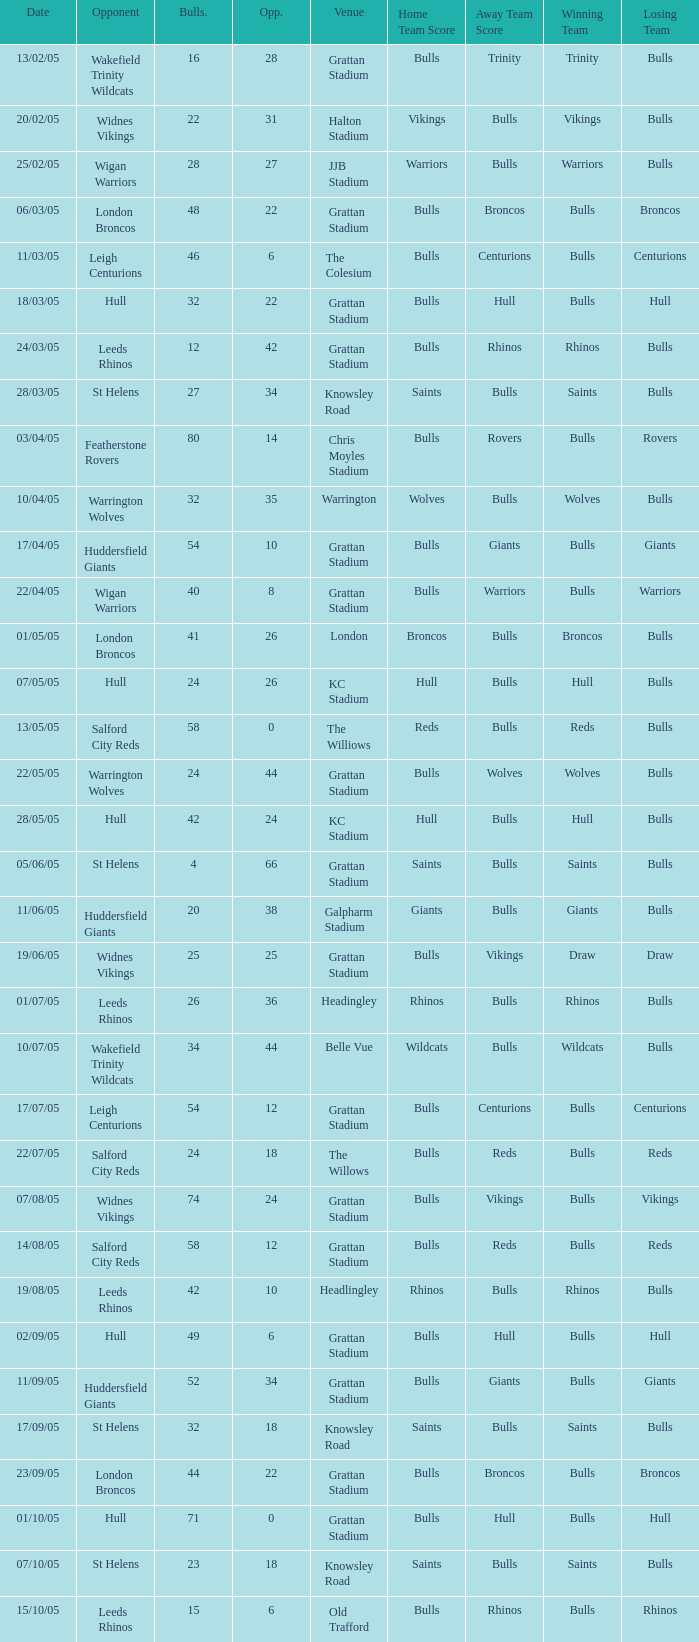What was the total number for the Bulls when they were at Old Trafford? 1.0. 